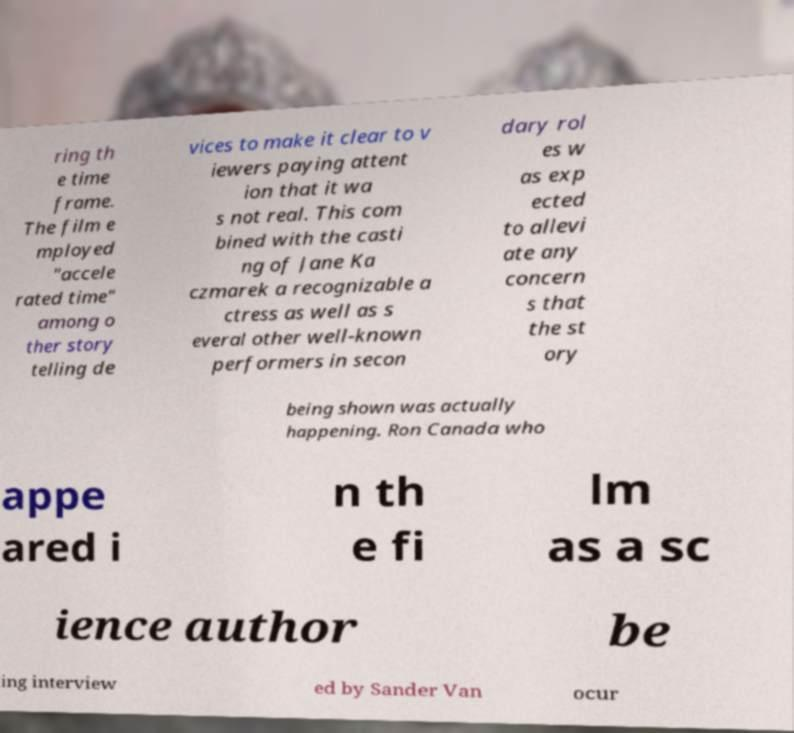Please read and relay the text visible in this image. What does it say? ring th e time frame. The film e mployed "accele rated time" among o ther story telling de vices to make it clear to v iewers paying attent ion that it wa s not real. This com bined with the casti ng of Jane Ka czmarek a recognizable a ctress as well as s everal other well-known performers in secon dary rol es w as exp ected to allevi ate any concern s that the st ory being shown was actually happening. Ron Canada who appe ared i n th e fi lm as a sc ience author be ing interview ed by Sander Van ocur 